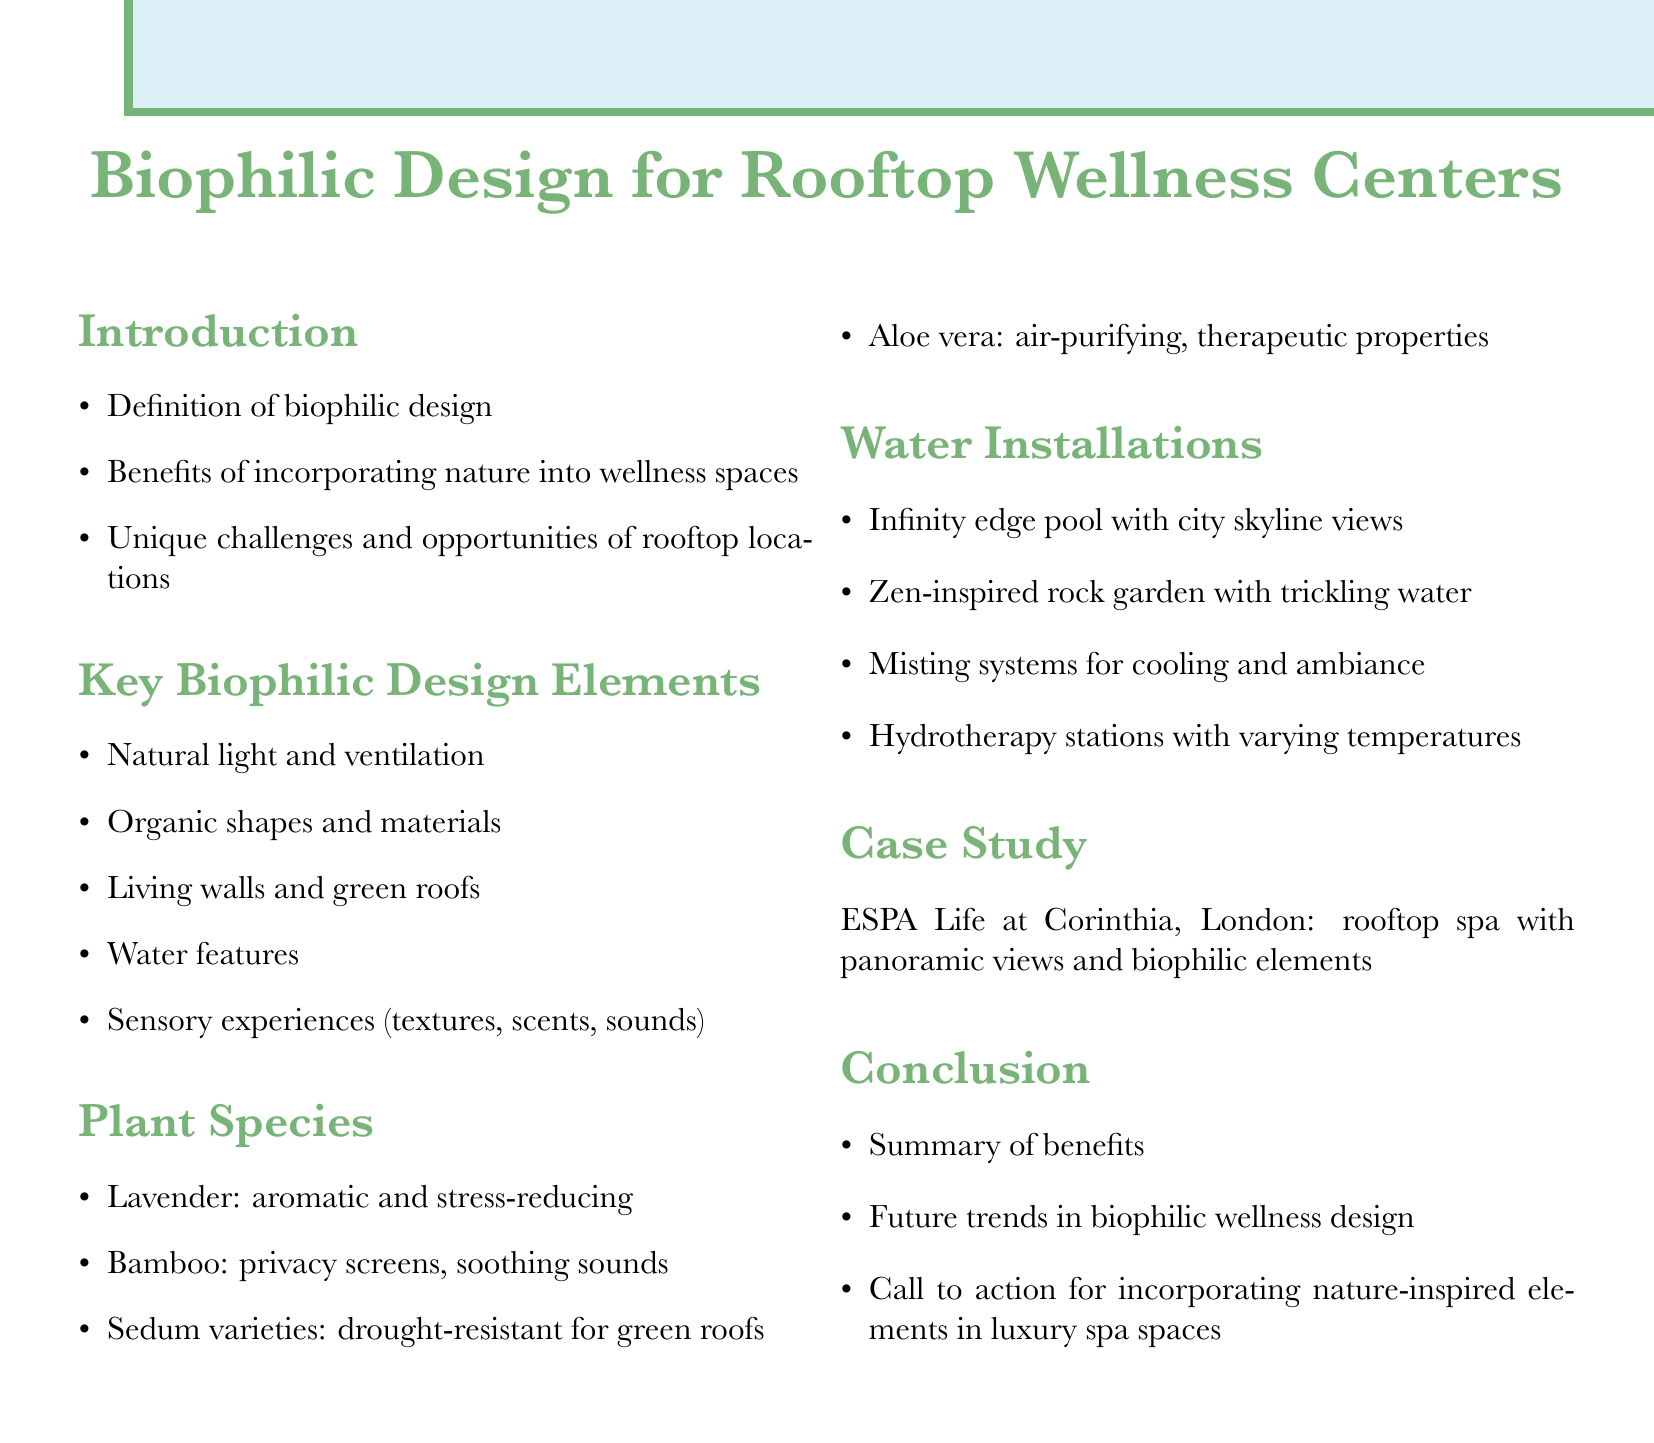What is biophilic design? The document defines biophilic design in the introduction section.
Answer: Biophilic design What are the benefits of incorporating nature into wellness spaces? The benefits are listed in the introduction section.
Answer: Stress reduction, enhanced well-being What is one example of a plant species for rooftop wellness centers? The document provides examples of plant species under the relevant section.
Answer: Lavender What type of water installation involves city skyline views? The specific type of water installation is mentioned in the water installations section.
Answer: Infinity edge pool Which case study is mentioned related to rooftop spa design? The case study is highlighted in its own section.
Answer: ESPA Life at Corinthia, London What is a key design element that enhances sensory experiences? The document identifies key design elements including sensory experiences in the respective section.
Answer: Textures, scents, sounds What is one challenge mentioned for rooftop wellness centers? Unique challenges are outlined in the introduction section.
Answer: Limited space What future trend is discussed in the conclusion? The conclusion talks about future trends in the context of the document’s theme.
Answer: Biophilic wellness design What type of plants are described as drought-resistant for green roofs? The specified plants are listed in the plant species section.
Answer: Sedum varieties 